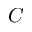<formula> <loc_0><loc_0><loc_500><loc_500>C</formula> 